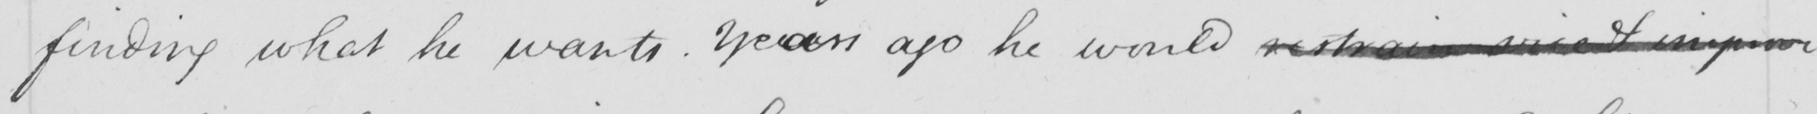Can you read and transcribe this handwriting? finding what he wants . Years ago he would restrain vice & improve 